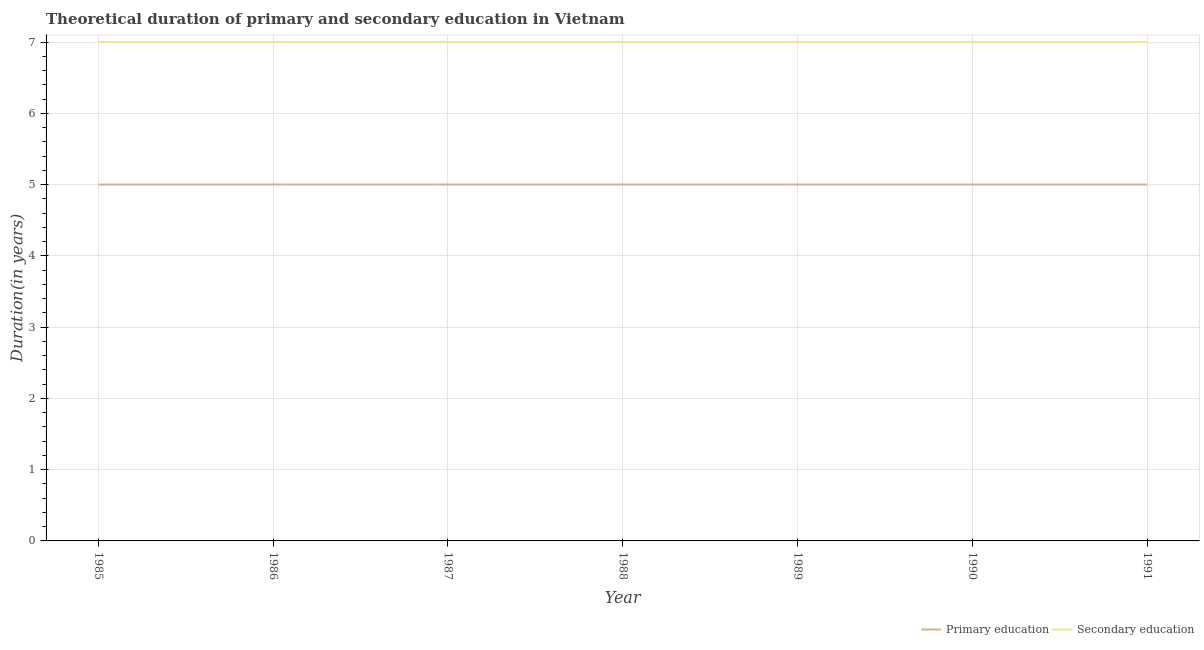What is the duration of primary education in 1987?
Your answer should be very brief. 5. Across all years, what is the maximum duration of secondary education?
Offer a very short reply. 7. Across all years, what is the minimum duration of secondary education?
Make the answer very short. 7. In which year was the duration of secondary education maximum?
Ensure brevity in your answer.  1985. In which year was the duration of secondary education minimum?
Your response must be concise. 1985. What is the total duration of secondary education in the graph?
Offer a terse response. 49. What is the difference between the duration of secondary education in 1986 and that in 1989?
Your answer should be compact. 0. What is the difference between the duration of secondary education in 1989 and the duration of primary education in 1988?
Keep it short and to the point. 2. What is the average duration of primary education per year?
Your answer should be compact. 5. In the year 1990, what is the difference between the duration of primary education and duration of secondary education?
Offer a terse response. -2. In how many years, is the duration of primary education greater than 5.2 years?
Ensure brevity in your answer.  0. What is the ratio of the duration of primary education in 1988 to that in 1989?
Your response must be concise. 1. Is the duration of primary education in 1987 less than that in 1991?
Offer a terse response. No. Is the difference between the duration of primary education in 1990 and 1991 greater than the difference between the duration of secondary education in 1990 and 1991?
Your response must be concise. No. What is the difference between the highest and the lowest duration of primary education?
Provide a succinct answer. 0. In how many years, is the duration of secondary education greater than the average duration of secondary education taken over all years?
Offer a terse response. 0. Is the sum of the duration of primary education in 1986 and 1987 greater than the maximum duration of secondary education across all years?
Provide a succinct answer. Yes. Does the duration of primary education monotonically increase over the years?
Your answer should be compact. No. Is the duration of secondary education strictly greater than the duration of primary education over the years?
Your response must be concise. Yes. Is the duration of secondary education strictly less than the duration of primary education over the years?
Keep it short and to the point. No. What is the difference between two consecutive major ticks on the Y-axis?
Ensure brevity in your answer.  1. Are the values on the major ticks of Y-axis written in scientific E-notation?
Offer a terse response. No. Does the graph contain any zero values?
Offer a very short reply. No. Where does the legend appear in the graph?
Your answer should be very brief. Bottom right. How many legend labels are there?
Offer a terse response. 2. How are the legend labels stacked?
Offer a very short reply. Horizontal. What is the title of the graph?
Ensure brevity in your answer.  Theoretical duration of primary and secondary education in Vietnam. What is the label or title of the Y-axis?
Keep it short and to the point. Duration(in years). What is the Duration(in years) of Primary education in 1985?
Your response must be concise. 5. What is the Duration(in years) in Secondary education in 1985?
Your answer should be compact. 7. What is the Duration(in years) of Primary education in 1986?
Ensure brevity in your answer.  5. What is the Duration(in years) of Secondary education in 1986?
Make the answer very short. 7. What is the Duration(in years) in Primary education in 1987?
Offer a very short reply. 5. What is the Duration(in years) in Secondary education in 1987?
Your answer should be very brief. 7. What is the Duration(in years) in Secondary education in 1989?
Your answer should be very brief. 7. Across all years, what is the minimum Duration(in years) in Primary education?
Offer a terse response. 5. What is the total Duration(in years) of Primary education in the graph?
Provide a short and direct response. 35. What is the difference between the Duration(in years) in Primary education in 1985 and that in 1986?
Your answer should be very brief. 0. What is the difference between the Duration(in years) in Secondary education in 1985 and that in 1986?
Offer a very short reply. 0. What is the difference between the Duration(in years) in Primary education in 1985 and that in 1987?
Provide a succinct answer. 0. What is the difference between the Duration(in years) of Secondary education in 1985 and that in 1988?
Offer a terse response. 0. What is the difference between the Duration(in years) in Primary education in 1985 and that in 1989?
Provide a short and direct response. 0. What is the difference between the Duration(in years) of Secondary education in 1985 and that in 1989?
Your answer should be very brief. 0. What is the difference between the Duration(in years) in Primary education in 1985 and that in 1990?
Provide a short and direct response. 0. What is the difference between the Duration(in years) of Primary education in 1985 and that in 1991?
Offer a very short reply. 0. What is the difference between the Duration(in years) of Secondary education in 1985 and that in 1991?
Ensure brevity in your answer.  0. What is the difference between the Duration(in years) in Secondary education in 1986 and that in 1987?
Offer a terse response. 0. What is the difference between the Duration(in years) in Primary education in 1986 and that in 1988?
Make the answer very short. 0. What is the difference between the Duration(in years) of Primary education in 1986 and that in 1990?
Ensure brevity in your answer.  0. What is the difference between the Duration(in years) of Secondary education in 1986 and that in 1990?
Provide a succinct answer. 0. What is the difference between the Duration(in years) of Primary education in 1986 and that in 1991?
Provide a short and direct response. 0. What is the difference between the Duration(in years) of Secondary education in 1986 and that in 1991?
Your response must be concise. 0. What is the difference between the Duration(in years) of Primary education in 1987 and that in 1989?
Keep it short and to the point. 0. What is the difference between the Duration(in years) of Secondary education in 1987 and that in 1990?
Provide a succinct answer. 0. What is the difference between the Duration(in years) of Primary education in 1988 and that in 1989?
Keep it short and to the point. 0. What is the difference between the Duration(in years) of Secondary education in 1988 and that in 1989?
Give a very brief answer. 0. What is the difference between the Duration(in years) of Primary education in 1988 and that in 1990?
Provide a short and direct response. 0. What is the difference between the Duration(in years) of Primary education in 1988 and that in 1991?
Your response must be concise. 0. What is the difference between the Duration(in years) in Secondary education in 1988 and that in 1991?
Your response must be concise. 0. What is the difference between the Duration(in years) in Primary education in 1989 and that in 1990?
Make the answer very short. 0. What is the difference between the Duration(in years) of Secondary education in 1989 and that in 1990?
Make the answer very short. 0. What is the difference between the Duration(in years) of Primary education in 1989 and that in 1991?
Provide a short and direct response. 0. What is the difference between the Duration(in years) in Secondary education in 1989 and that in 1991?
Offer a terse response. 0. What is the difference between the Duration(in years) of Primary education in 1985 and the Duration(in years) of Secondary education in 1990?
Your answer should be very brief. -2. What is the difference between the Duration(in years) of Primary education in 1986 and the Duration(in years) of Secondary education in 1989?
Offer a very short reply. -2. What is the difference between the Duration(in years) of Primary education in 1986 and the Duration(in years) of Secondary education in 1991?
Offer a terse response. -2. What is the difference between the Duration(in years) of Primary education in 1987 and the Duration(in years) of Secondary education in 1989?
Your answer should be very brief. -2. What is the difference between the Duration(in years) in Primary education in 1987 and the Duration(in years) in Secondary education in 1990?
Your answer should be compact. -2. What is the difference between the Duration(in years) in Primary education in 1987 and the Duration(in years) in Secondary education in 1991?
Your answer should be very brief. -2. What is the difference between the Duration(in years) in Primary education in 1988 and the Duration(in years) in Secondary education in 1989?
Offer a very short reply. -2. What is the difference between the Duration(in years) of Primary education in 1988 and the Duration(in years) of Secondary education in 1990?
Your response must be concise. -2. What is the difference between the Duration(in years) in Primary education in 1989 and the Duration(in years) in Secondary education in 1990?
Provide a succinct answer. -2. In the year 1988, what is the difference between the Duration(in years) of Primary education and Duration(in years) of Secondary education?
Your answer should be compact. -2. In the year 1989, what is the difference between the Duration(in years) of Primary education and Duration(in years) of Secondary education?
Give a very brief answer. -2. In the year 1990, what is the difference between the Duration(in years) of Primary education and Duration(in years) of Secondary education?
Your answer should be very brief. -2. What is the ratio of the Duration(in years) of Primary education in 1985 to that in 1986?
Offer a very short reply. 1. What is the ratio of the Duration(in years) in Primary education in 1985 to that in 1987?
Your answer should be very brief. 1. What is the ratio of the Duration(in years) in Secondary education in 1985 to that in 1987?
Ensure brevity in your answer.  1. What is the ratio of the Duration(in years) of Secondary education in 1985 to that in 1988?
Offer a very short reply. 1. What is the ratio of the Duration(in years) of Primary education in 1985 to that in 1990?
Make the answer very short. 1. What is the ratio of the Duration(in years) of Secondary education in 1985 to that in 1991?
Offer a terse response. 1. What is the ratio of the Duration(in years) of Primary education in 1986 to that in 1987?
Your response must be concise. 1. What is the ratio of the Duration(in years) in Secondary education in 1986 to that in 1987?
Your answer should be very brief. 1. What is the ratio of the Duration(in years) in Primary education in 1986 to that in 1989?
Provide a short and direct response. 1. What is the ratio of the Duration(in years) of Primary education in 1986 to that in 1990?
Provide a succinct answer. 1. What is the ratio of the Duration(in years) in Secondary education in 1986 to that in 1990?
Your answer should be very brief. 1. What is the ratio of the Duration(in years) in Primary education in 1986 to that in 1991?
Your answer should be very brief. 1. What is the ratio of the Duration(in years) in Secondary education in 1986 to that in 1991?
Offer a very short reply. 1. What is the ratio of the Duration(in years) of Primary education in 1987 to that in 1988?
Offer a terse response. 1. What is the ratio of the Duration(in years) of Secondary education in 1987 to that in 1988?
Your answer should be very brief. 1. What is the ratio of the Duration(in years) of Primary education in 1987 to that in 1989?
Your answer should be compact. 1. What is the ratio of the Duration(in years) in Secondary education in 1987 to that in 1989?
Give a very brief answer. 1. What is the ratio of the Duration(in years) of Primary education in 1987 to that in 1990?
Ensure brevity in your answer.  1. What is the ratio of the Duration(in years) of Primary education in 1988 to that in 1989?
Make the answer very short. 1. What is the ratio of the Duration(in years) in Secondary education in 1988 to that in 1989?
Provide a succinct answer. 1. What is the ratio of the Duration(in years) of Secondary education in 1988 to that in 1991?
Offer a terse response. 1. What is the ratio of the Duration(in years) in Primary education in 1989 to that in 1990?
Give a very brief answer. 1. What is the difference between the highest and the second highest Duration(in years) of Primary education?
Ensure brevity in your answer.  0. What is the difference between the highest and the second highest Duration(in years) in Secondary education?
Give a very brief answer. 0. What is the difference between the highest and the lowest Duration(in years) in Secondary education?
Offer a very short reply. 0. 